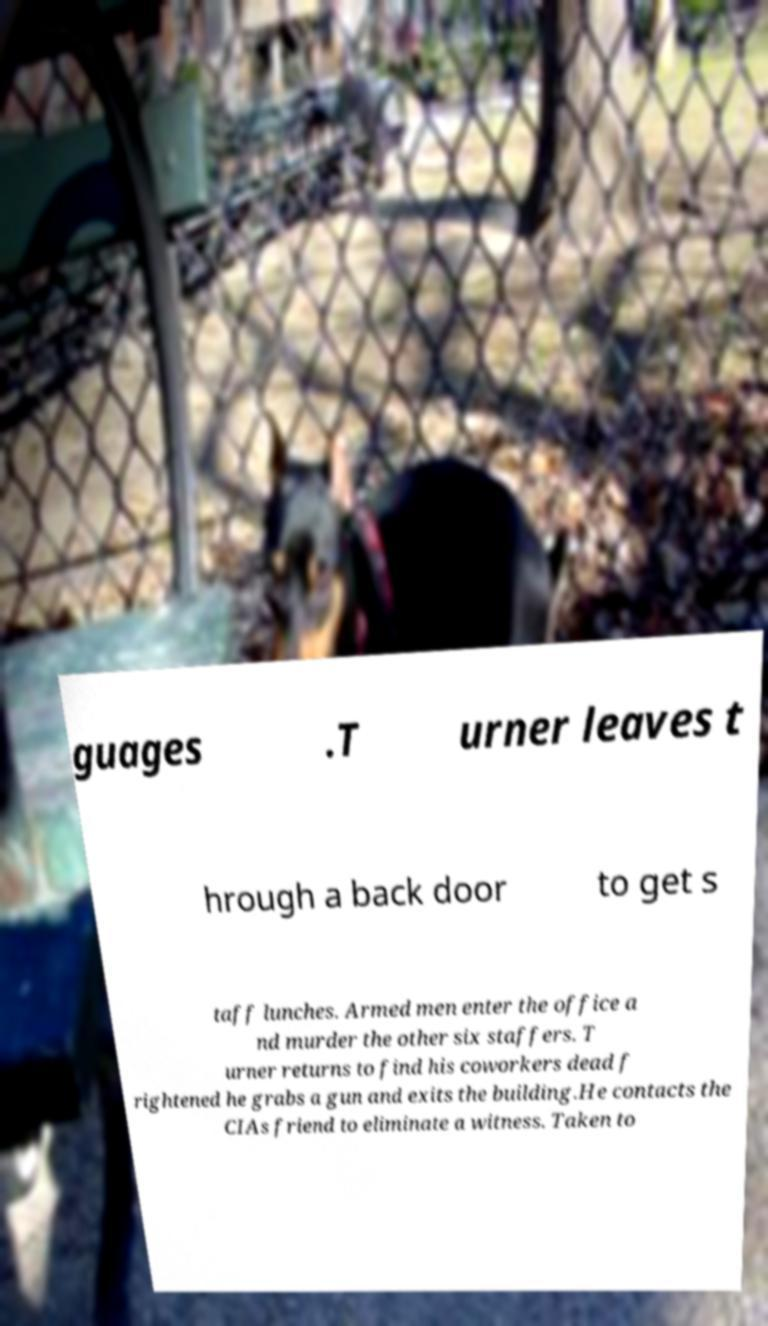There's text embedded in this image that I need extracted. Can you transcribe it verbatim? guages .T urner leaves t hrough a back door to get s taff lunches. Armed men enter the office a nd murder the other six staffers. T urner returns to find his coworkers dead f rightened he grabs a gun and exits the building.He contacts the CIAs friend to eliminate a witness. Taken to 